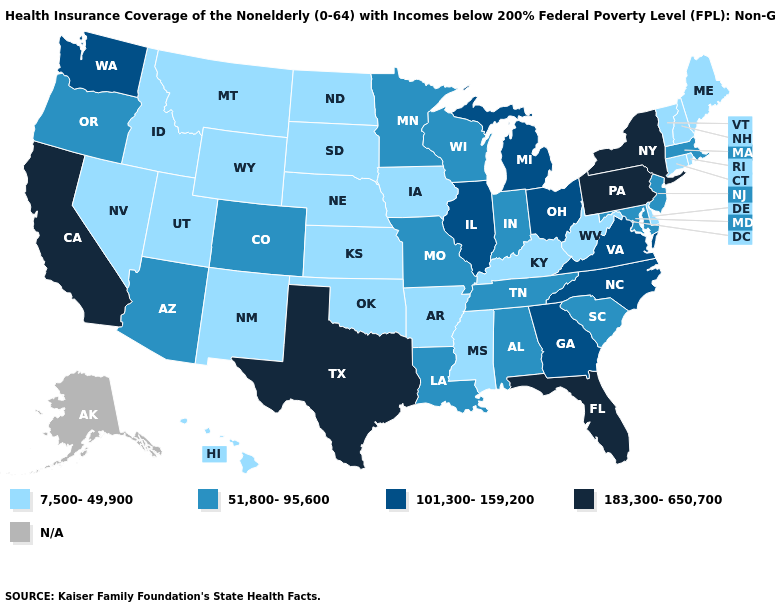Name the states that have a value in the range N/A?
Give a very brief answer. Alaska. What is the value of Tennessee?
Give a very brief answer. 51,800-95,600. Which states hav the highest value in the MidWest?
Answer briefly. Illinois, Michigan, Ohio. What is the value of Kentucky?
Quick response, please. 7,500-49,900. Does the map have missing data?
Be succinct. Yes. What is the highest value in the MidWest ?
Concise answer only. 101,300-159,200. Among the states that border Mississippi , does Arkansas have the lowest value?
Give a very brief answer. Yes. What is the value of Idaho?
Answer briefly. 7,500-49,900. What is the lowest value in the South?
Be succinct. 7,500-49,900. What is the value of Nevada?
Short answer required. 7,500-49,900. Among the states that border South Carolina , which have the lowest value?
Give a very brief answer. Georgia, North Carolina. Among the states that border Kentucky , which have the lowest value?
Quick response, please. West Virginia. Name the states that have a value in the range 51,800-95,600?
Concise answer only. Alabama, Arizona, Colorado, Indiana, Louisiana, Maryland, Massachusetts, Minnesota, Missouri, New Jersey, Oregon, South Carolina, Tennessee, Wisconsin. 